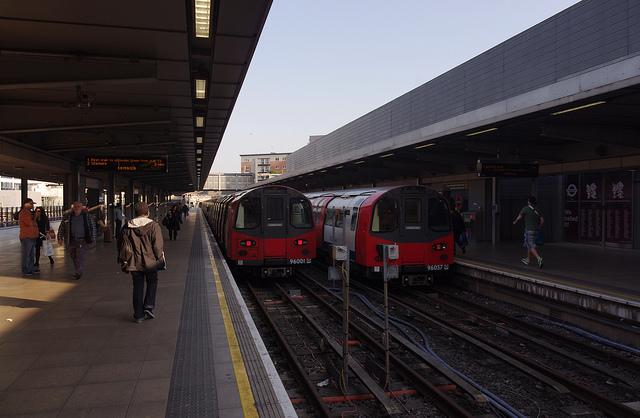What information does such an electronic billboard depict in this scenario? train times 